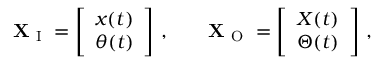<formula> <loc_0><loc_0><loc_500><loc_500>X _ { I } = \left [ \begin{array} { l } { x ( t ) } \\ { \theta ( t ) } \end{array} \right ] \, , \quad X _ { O } = \left [ \begin{array} { l } { X ( t ) } \\ { \Theta ( t ) } \end{array} \right ] \, ,</formula> 